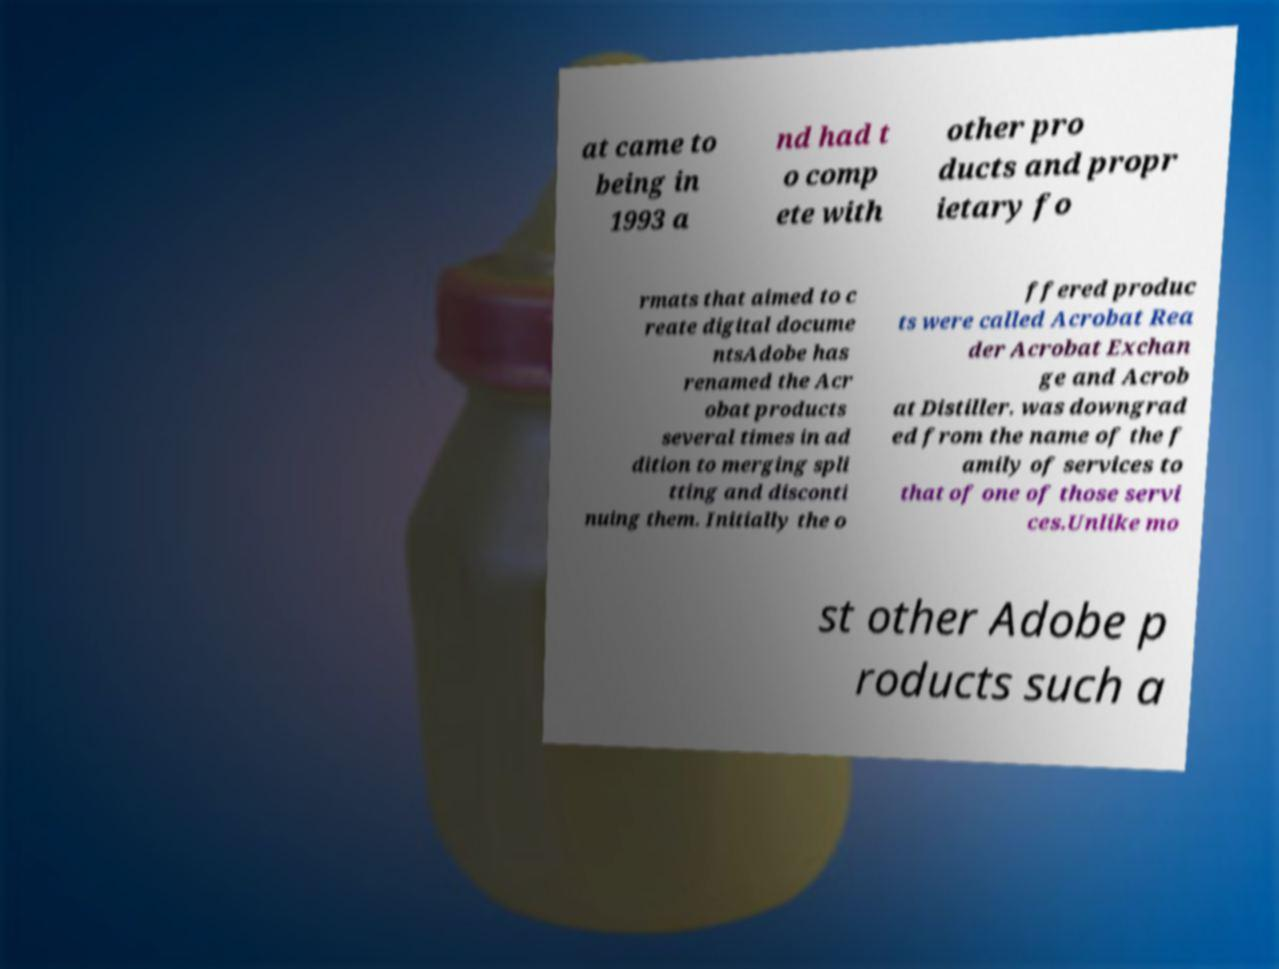Can you accurately transcribe the text from the provided image for me? at came to being in 1993 a nd had t o comp ete with other pro ducts and propr ietary fo rmats that aimed to c reate digital docume ntsAdobe has renamed the Acr obat products several times in ad dition to merging spli tting and disconti nuing them. Initially the o ffered produc ts were called Acrobat Rea der Acrobat Exchan ge and Acrob at Distiller. was downgrad ed from the name of the f amily of services to that of one of those servi ces.Unlike mo st other Adobe p roducts such a 